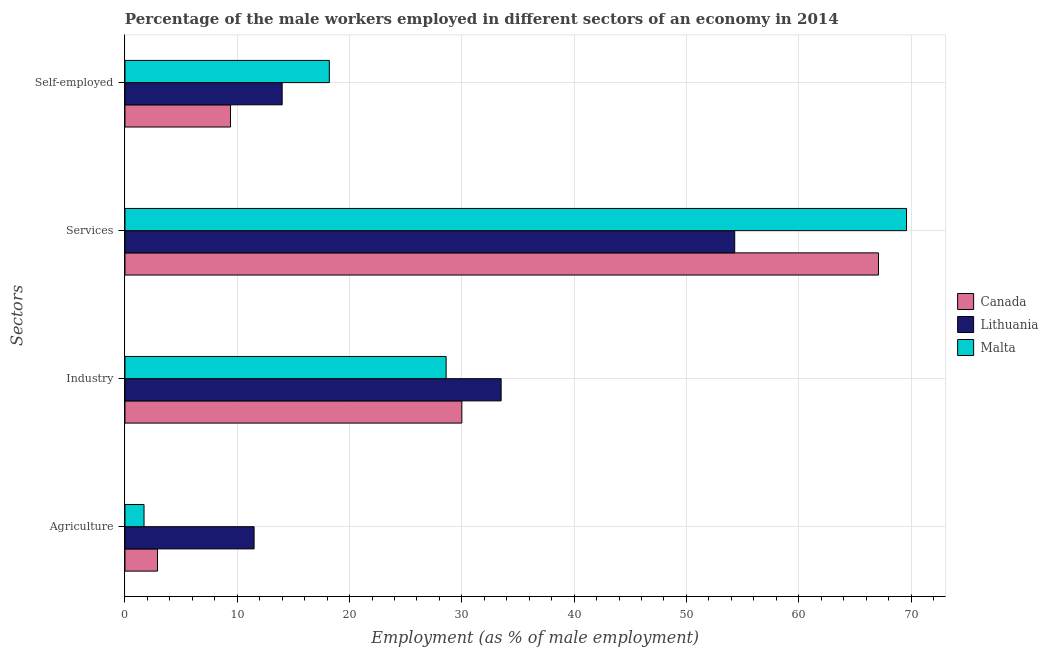How many different coloured bars are there?
Offer a very short reply. 3. Are the number of bars per tick equal to the number of legend labels?
Offer a terse response. Yes. Are the number of bars on each tick of the Y-axis equal?
Your response must be concise. Yes. How many bars are there on the 1st tick from the bottom?
Offer a very short reply. 3. What is the label of the 3rd group of bars from the top?
Your answer should be very brief. Industry. What is the percentage of self employed male workers in Canada?
Provide a succinct answer. 9.4. Across all countries, what is the maximum percentage of self employed male workers?
Make the answer very short. 18.2. Across all countries, what is the minimum percentage of self employed male workers?
Give a very brief answer. 9.4. In which country was the percentage of self employed male workers maximum?
Make the answer very short. Malta. In which country was the percentage of male workers in agriculture minimum?
Give a very brief answer. Malta. What is the total percentage of male workers in services in the graph?
Provide a short and direct response. 191. What is the difference between the percentage of self employed male workers in Lithuania and that in Canada?
Your answer should be very brief. 4.6. What is the difference between the percentage of self employed male workers in Lithuania and the percentage of male workers in services in Malta?
Provide a succinct answer. -55.6. What is the average percentage of male workers in services per country?
Provide a short and direct response. 63.67. What is the difference between the percentage of self employed male workers and percentage of male workers in industry in Malta?
Your answer should be very brief. -10.4. What is the ratio of the percentage of male workers in agriculture in Lithuania to that in Malta?
Provide a succinct answer. 6.76. Is the difference between the percentage of male workers in services in Lithuania and Malta greater than the difference between the percentage of self employed male workers in Lithuania and Malta?
Your answer should be compact. No. What is the difference between the highest and the second highest percentage of male workers in services?
Offer a very short reply. 2.5. What is the difference between the highest and the lowest percentage of male workers in services?
Offer a very short reply. 15.3. Is the sum of the percentage of male workers in industry in Malta and Lithuania greater than the maximum percentage of self employed male workers across all countries?
Provide a succinct answer. Yes. What does the 3rd bar from the bottom in Services represents?
Keep it short and to the point. Malta. Is it the case that in every country, the sum of the percentage of male workers in agriculture and percentage of male workers in industry is greater than the percentage of male workers in services?
Your answer should be very brief. No. Are the values on the major ticks of X-axis written in scientific E-notation?
Offer a very short reply. No. Where does the legend appear in the graph?
Offer a terse response. Center right. What is the title of the graph?
Provide a succinct answer. Percentage of the male workers employed in different sectors of an economy in 2014. What is the label or title of the X-axis?
Ensure brevity in your answer.  Employment (as % of male employment). What is the label or title of the Y-axis?
Offer a very short reply. Sectors. What is the Employment (as % of male employment) in Canada in Agriculture?
Provide a succinct answer. 2.9. What is the Employment (as % of male employment) in Malta in Agriculture?
Make the answer very short. 1.7. What is the Employment (as % of male employment) of Canada in Industry?
Provide a short and direct response. 30. What is the Employment (as % of male employment) of Lithuania in Industry?
Your response must be concise. 33.5. What is the Employment (as % of male employment) of Malta in Industry?
Offer a very short reply. 28.6. What is the Employment (as % of male employment) of Canada in Services?
Your answer should be compact. 67.1. What is the Employment (as % of male employment) in Lithuania in Services?
Offer a terse response. 54.3. What is the Employment (as % of male employment) in Malta in Services?
Provide a succinct answer. 69.6. What is the Employment (as % of male employment) of Canada in Self-employed?
Make the answer very short. 9.4. What is the Employment (as % of male employment) of Lithuania in Self-employed?
Offer a very short reply. 14. What is the Employment (as % of male employment) of Malta in Self-employed?
Your response must be concise. 18.2. Across all Sectors, what is the maximum Employment (as % of male employment) of Canada?
Provide a short and direct response. 67.1. Across all Sectors, what is the maximum Employment (as % of male employment) of Lithuania?
Offer a very short reply. 54.3. Across all Sectors, what is the maximum Employment (as % of male employment) of Malta?
Provide a succinct answer. 69.6. Across all Sectors, what is the minimum Employment (as % of male employment) in Canada?
Your answer should be very brief. 2.9. Across all Sectors, what is the minimum Employment (as % of male employment) in Lithuania?
Your answer should be compact. 11.5. Across all Sectors, what is the minimum Employment (as % of male employment) of Malta?
Give a very brief answer. 1.7. What is the total Employment (as % of male employment) of Canada in the graph?
Make the answer very short. 109.4. What is the total Employment (as % of male employment) in Lithuania in the graph?
Your answer should be very brief. 113.3. What is the total Employment (as % of male employment) in Malta in the graph?
Your response must be concise. 118.1. What is the difference between the Employment (as % of male employment) of Canada in Agriculture and that in Industry?
Your response must be concise. -27.1. What is the difference between the Employment (as % of male employment) of Malta in Agriculture and that in Industry?
Your response must be concise. -26.9. What is the difference between the Employment (as % of male employment) in Canada in Agriculture and that in Services?
Keep it short and to the point. -64.2. What is the difference between the Employment (as % of male employment) in Lithuania in Agriculture and that in Services?
Your response must be concise. -42.8. What is the difference between the Employment (as % of male employment) of Malta in Agriculture and that in Services?
Keep it short and to the point. -67.9. What is the difference between the Employment (as % of male employment) in Canada in Agriculture and that in Self-employed?
Your response must be concise. -6.5. What is the difference between the Employment (as % of male employment) in Malta in Agriculture and that in Self-employed?
Give a very brief answer. -16.5. What is the difference between the Employment (as % of male employment) in Canada in Industry and that in Services?
Give a very brief answer. -37.1. What is the difference between the Employment (as % of male employment) in Lithuania in Industry and that in Services?
Provide a short and direct response. -20.8. What is the difference between the Employment (as % of male employment) of Malta in Industry and that in Services?
Offer a very short reply. -41. What is the difference between the Employment (as % of male employment) of Canada in Industry and that in Self-employed?
Offer a very short reply. 20.6. What is the difference between the Employment (as % of male employment) of Malta in Industry and that in Self-employed?
Your answer should be very brief. 10.4. What is the difference between the Employment (as % of male employment) of Canada in Services and that in Self-employed?
Your answer should be compact. 57.7. What is the difference between the Employment (as % of male employment) in Lithuania in Services and that in Self-employed?
Your response must be concise. 40.3. What is the difference between the Employment (as % of male employment) in Malta in Services and that in Self-employed?
Keep it short and to the point. 51.4. What is the difference between the Employment (as % of male employment) of Canada in Agriculture and the Employment (as % of male employment) of Lithuania in Industry?
Your response must be concise. -30.6. What is the difference between the Employment (as % of male employment) of Canada in Agriculture and the Employment (as % of male employment) of Malta in Industry?
Ensure brevity in your answer.  -25.7. What is the difference between the Employment (as % of male employment) in Lithuania in Agriculture and the Employment (as % of male employment) in Malta in Industry?
Your answer should be very brief. -17.1. What is the difference between the Employment (as % of male employment) in Canada in Agriculture and the Employment (as % of male employment) in Lithuania in Services?
Provide a short and direct response. -51.4. What is the difference between the Employment (as % of male employment) in Canada in Agriculture and the Employment (as % of male employment) in Malta in Services?
Provide a succinct answer. -66.7. What is the difference between the Employment (as % of male employment) of Lithuania in Agriculture and the Employment (as % of male employment) of Malta in Services?
Offer a very short reply. -58.1. What is the difference between the Employment (as % of male employment) in Canada in Agriculture and the Employment (as % of male employment) in Malta in Self-employed?
Offer a very short reply. -15.3. What is the difference between the Employment (as % of male employment) in Lithuania in Agriculture and the Employment (as % of male employment) in Malta in Self-employed?
Make the answer very short. -6.7. What is the difference between the Employment (as % of male employment) of Canada in Industry and the Employment (as % of male employment) of Lithuania in Services?
Your answer should be very brief. -24.3. What is the difference between the Employment (as % of male employment) of Canada in Industry and the Employment (as % of male employment) of Malta in Services?
Provide a short and direct response. -39.6. What is the difference between the Employment (as % of male employment) of Lithuania in Industry and the Employment (as % of male employment) of Malta in Services?
Ensure brevity in your answer.  -36.1. What is the difference between the Employment (as % of male employment) of Canada in Industry and the Employment (as % of male employment) of Lithuania in Self-employed?
Offer a terse response. 16. What is the difference between the Employment (as % of male employment) in Canada in Industry and the Employment (as % of male employment) in Malta in Self-employed?
Give a very brief answer. 11.8. What is the difference between the Employment (as % of male employment) in Lithuania in Industry and the Employment (as % of male employment) in Malta in Self-employed?
Ensure brevity in your answer.  15.3. What is the difference between the Employment (as % of male employment) of Canada in Services and the Employment (as % of male employment) of Lithuania in Self-employed?
Your response must be concise. 53.1. What is the difference between the Employment (as % of male employment) in Canada in Services and the Employment (as % of male employment) in Malta in Self-employed?
Make the answer very short. 48.9. What is the difference between the Employment (as % of male employment) in Lithuania in Services and the Employment (as % of male employment) in Malta in Self-employed?
Your answer should be very brief. 36.1. What is the average Employment (as % of male employment) in Canada per Sectors?
Make the answer very short. 27.35. What is the average Employment (as % of male employment) of Lithuania per Sectors?
Make the answer very short. 28.32. What is the average Employment (as % of male employment) in Malta per Sectors?
Keep it short and to the point. 29.52. What is the difference between the Employment (as % of male employment) in Canada and Employment (as % of male employment) in Malta in Agriculture?
Offer a very short reply. 1.2. What is the difference between the Employment (as % of male employment) of Lithuania and Employment (as % of male employment) of Malta in Agriculture?
Your response must be concise. 9.8. What is the difference between the Employment (as % of male employment) in Canada and Employment (as % of male employment) in Malta in Services?
Your answer should be compact. -2.5. What is the difference between the Employment (as % of male employment) of Lithuania and Employment (as % of male employment) of Malta in Services?
Keep it short and to the point. -15.3. What is the difference between the Employment (as % of male employment) of Canada and Employment (as % of male employment) of Lithuania in Self-employed?
Provide a succinct answer. -4.6. What is the difference between the Employment (as % of male employment) of Canada and Employment (as % of male employment) of Malta in Self-employed?
Your response must be concise. -8.8. What is the ratio of the Employment (as % of male employment) of Canada in Agriculture to that in Industry?
Your answer should be compact. 0.1. What is the ratio of the Employment (as % of male employment) of Lithuania in Agriculture to that in Industry?
Give a very brief answer. 0.34. What is the ratio of the Employment (as % of male employment) in Malta in Agriculture to that in Industry?
Your answer should be compact. 0.06. What is the ratio of the Employment (as % of male employment) of Canada in Agriculture to that in Services?
Keep it short and to the point. 0.04. What is the ratio of the Employment (as % of male employment) in Lithuania in Agriculture to that in Services?
Offer a terse response. 0.21. What is the ratio of the Employment (as % of male employment) in Malta in Agriculture to that in Services?
Offer a terse response. 0.02. What is the ratio of the Employment (as % of male employment) in Canada in Agriculture to that in Self-employed?
Your answer should be very brief. 0.31. What is the ratio of the Employment (as % of male employment) in Lithuania in Agriculture to that in Self-employed?
Ensure brevity in your answer.  0.82. What is the ratio of the Employment (as % of male employment) in Malta in Agriculture to that in Self-employed?
Keep it short and to the point. 0.09. What is the ratio of the Employment (as % of male employment) of Canada in Industry to that in Services?
Provide a succinct answer. 0.45. What is the ratio of the Employment (as % of male employment) in Lithuania in Industry to that in Services?
Make the answer very short. 0.62. What is the ratio of the Employment (as % of male employment) of Malta in Industry to that in Services?
Make the answer very short. 0.41. What is the ratio of the Employment (as % of male employment) of Canada in Industry to that in Self-employed?
Ensure brevity in your answer.  3.19. What is the ratio of the Employment (as % of male employment) of Lithuania in Industry to that in Self-employed?
Your response must be concise. 2.39. What is the ratio of the Employment (as % of male employment) in Malta in Industry to that in Self-employed?
Offer a very short reply. 1.57. What is the ratio of the Employment (as % of male employment) of Canada in Services to that in Self-employed?
Ensure brevity in your answer.  7.14. What is the ratio of the Employment (as % of male employment) in Lithuania in Services to that in Self-employed?
Keep it short and to the point. 3.88. What is the ratio of the Employment (as % of male employment) in Malta in Services to that in Self-employed?
Your answer should be very brief. 3.82. What is the difference between the highest and the second highest Employment (as % of male employment) in Canada?
Offer a terse response. 37.1. What is the difference between the highest and the second highest Employment (as % of male employment) in Lithuania?
Provide a short and direct response. 20.8. What is the difference between the highest and the second highest Employment (as % of male employment) of Malta?
Your answer should be very brief. 41. What is the difference between the highest and the lowest Employment (as % of male employment) of Canada?
Provide a short and direct response. 64.2. What is the difference between the highest and the lowest Employment (as % of male employment) in Lithuania?
Offer a very short reply. 42.8. What is the difference between the highest and the lowest Employment (as % of male employment) in Malta?
Offer a very short reply. 67.9. 